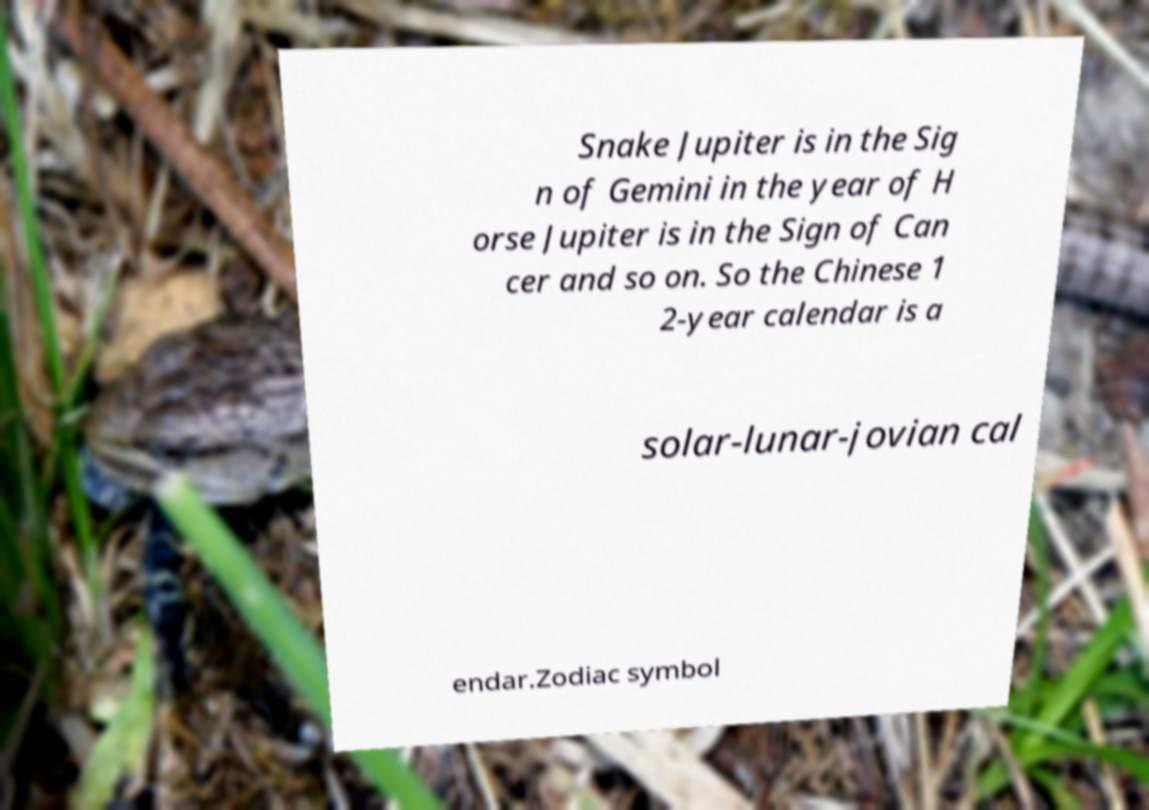Could you extract and type out the text from this image? Snake Jupiter is in the Sig n of Gemini in the year of H orse Jupiter is in the Sign of Can cer and so on. So the Chinese 1 2-year calendar is a solar-lunar-jovian cal endar.Zodiac symbol 